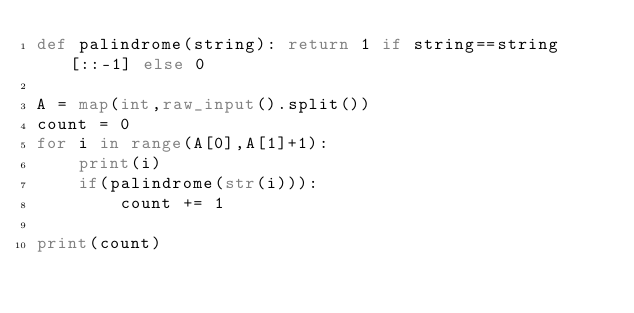<code> <loc_0><loc_0><loc_500><loc_500><_Python_>def palindrome(string): return 1 if string==string[::-1] else 0

A = map(int,raw_input().split())
count = 0
for i in range(A[0],A[1]+1):
    print(i)
    if(palindrome(str(i))):
        count += 1
    
print(count)

</code> 